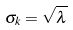Convert formula to latex. <formula><loc_0><loc_0><loc_500><loc_500>\sigma _ { k } = \sqrt { \lambda }</formula> 